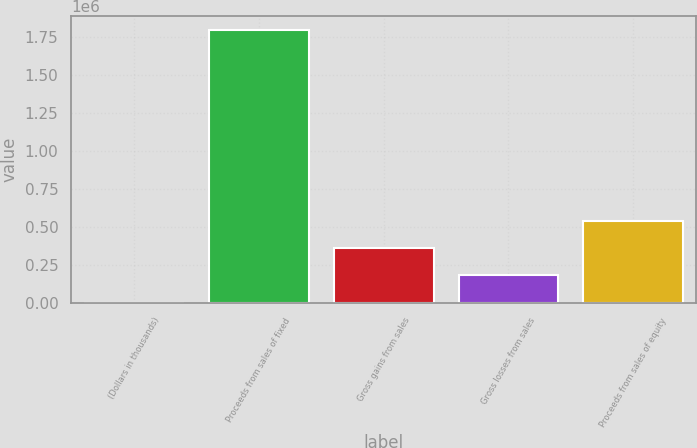Convert chart to OTSL. <chart><loc_0><loc_0><loc_500><loc_500><bar_chart><fcel>(Dollars in thousands)<fcel>Proceeds from sales of fixed<fcel>Gross gains from sales<fcel>Gross losses from sales<fcel>Proceeds from sales of equity<nl><fcel>2011<fcel>1.7974e+06<fcel>361090<fcel>181550<fcel>540629<nl></chart> 